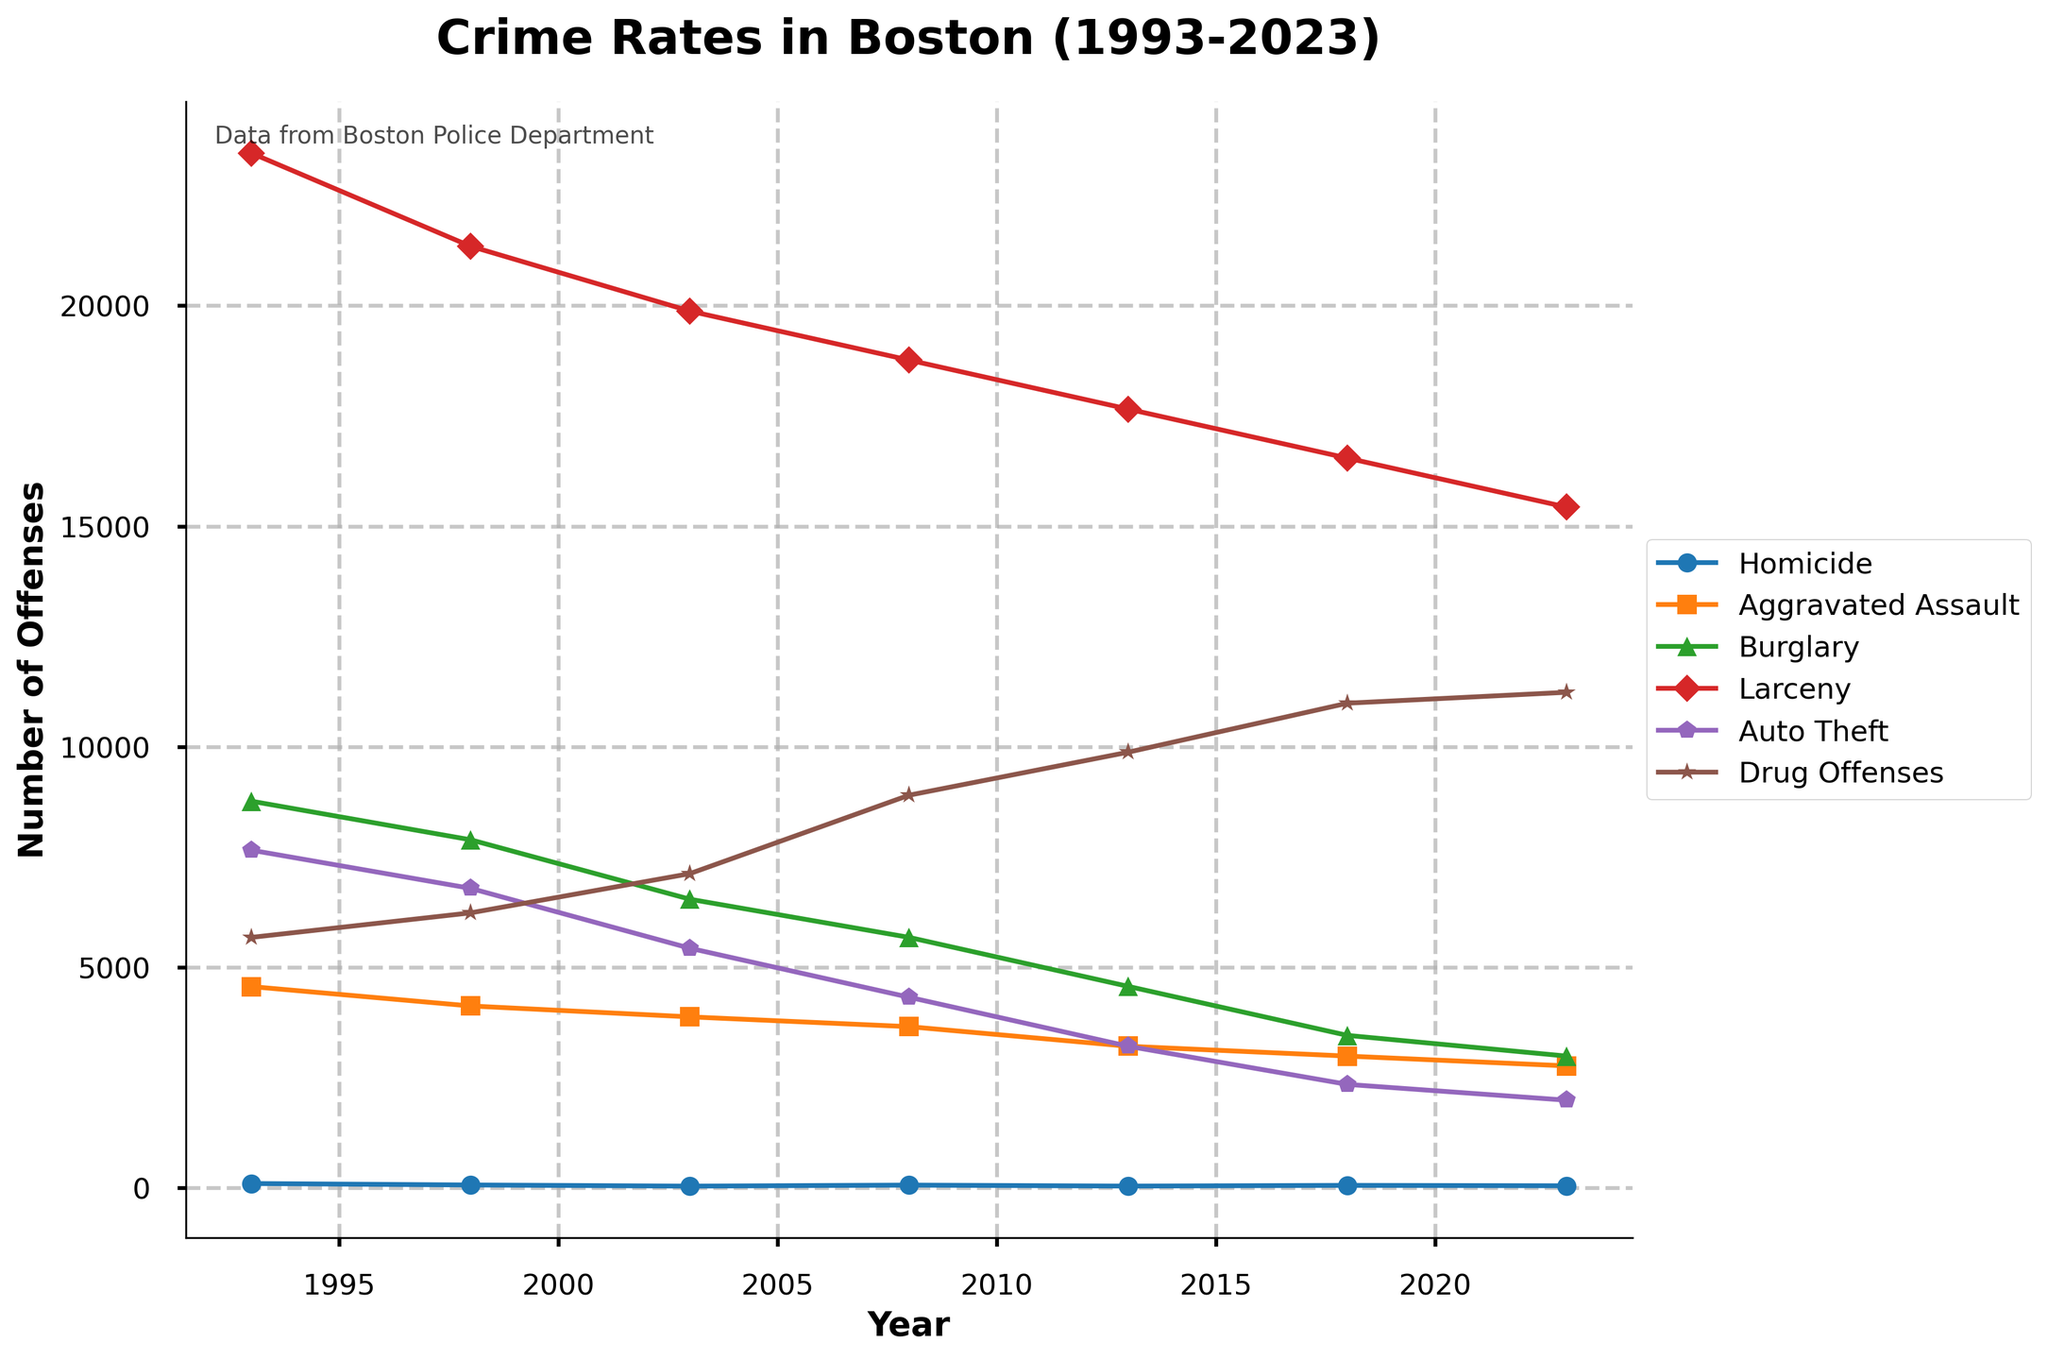What is the overall trend in the number of Homicides from 1993 to 2023? The trend in the Homicide rate shows an overall decrease from 1993, with fluctuations in certain years. Specifically, there was a significant decline from 98 in 1993 to about 39 in 2003, but a slight increase in recent years, peaking at 62 in 2008 but ending at 47 in 2023.
Answer: Decreasing trend with fluctuations Which year had the highest number of Aggravated Assaults, and what was the number? By examining the peaks for Aggravated Assaults, it is highest at the start of the time series in 1993. That year recorded 4562 incidents.
Answer: 1993, 4562 How did the number of Burglary offenses change between 2003 and 2023? The number of Burglary offenses reduced consistently between 2003 and 2023. It dropped from 6543 in 2003 to 2987 in 2023. This trend indicates a downward trajectory in Burglary offenses over the two-decade period.
Answer: Decreased from 6543 to 2987 Between which consecutive years was the largest drop in Larceny offenses observed? We look at the differences between consecutive years’ values for Larceny. The largest drop is between 2003 (19876) and 2008 (18765), with a decrease of 1111 offenses.
Answer: 2003 to 2008 What was the average number of Auto Theft incidents across the 30 years shown? To find the average, add the number of Auto Theft incidents from each year and divide by the number of years (1993-2023). Sum of incidents = 7654 + 6789 + 5432 + 4321 + 3210 + 2345 + 1987 = 31738. Average = 31738 / 7 ≈ 4534.
Answer: 4534 Which offense type had a consistent decline throughout almost all years? Reviewing each line, Burglary consistently declines through almost all years from the initial data point of 8765 in 1993 to 2987 in 2023 without substantial increase.
Answer: Burglary How does the latest data (2023) for Drug Offenses compare with the year it peaked? Drug Offenses in 2023 is 11234. The peak is observed in 2018 at 10987. Comparing these values, the 2023 figure is higher.
Answer: Higher in 2023 What is the cumulative number of Homicide offenses reported from 1993 to 2023? To find the cumulative number, sum all the Homicide numbers from each year. The sum is 98 + 65 + 39 + 62 + 40 + 56 + 47 = 407.
Answer: 407 During which period was there the most significant decrease in Auto Theft incidents? Examining the differences over periods, the most significant decrease in Auto Theft was observed between 2003 (5432) and 2008 (4321), where it drops by 1111.
Answer: 2003 to 2008 